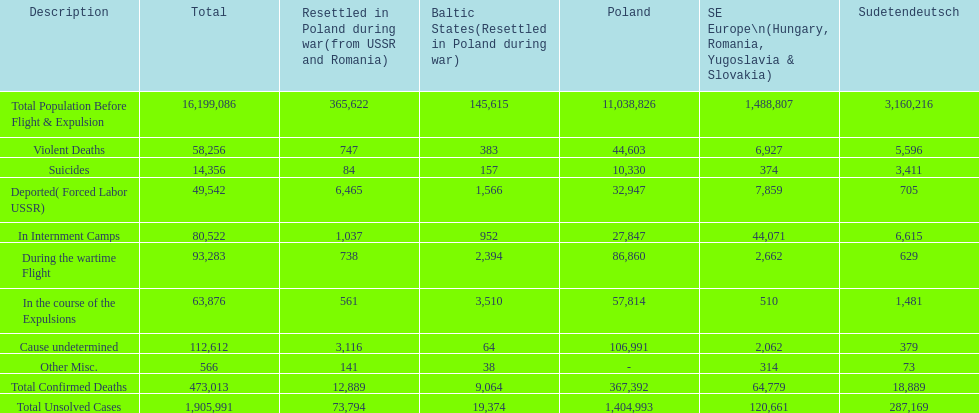Were there more cause undetermined or miscellaneous deaths in the baltic states? Cause undetermined. 